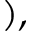Convert formula to latex. <formula><loc_0><loc_0><loc_500><loc_500>) ,</formula> 